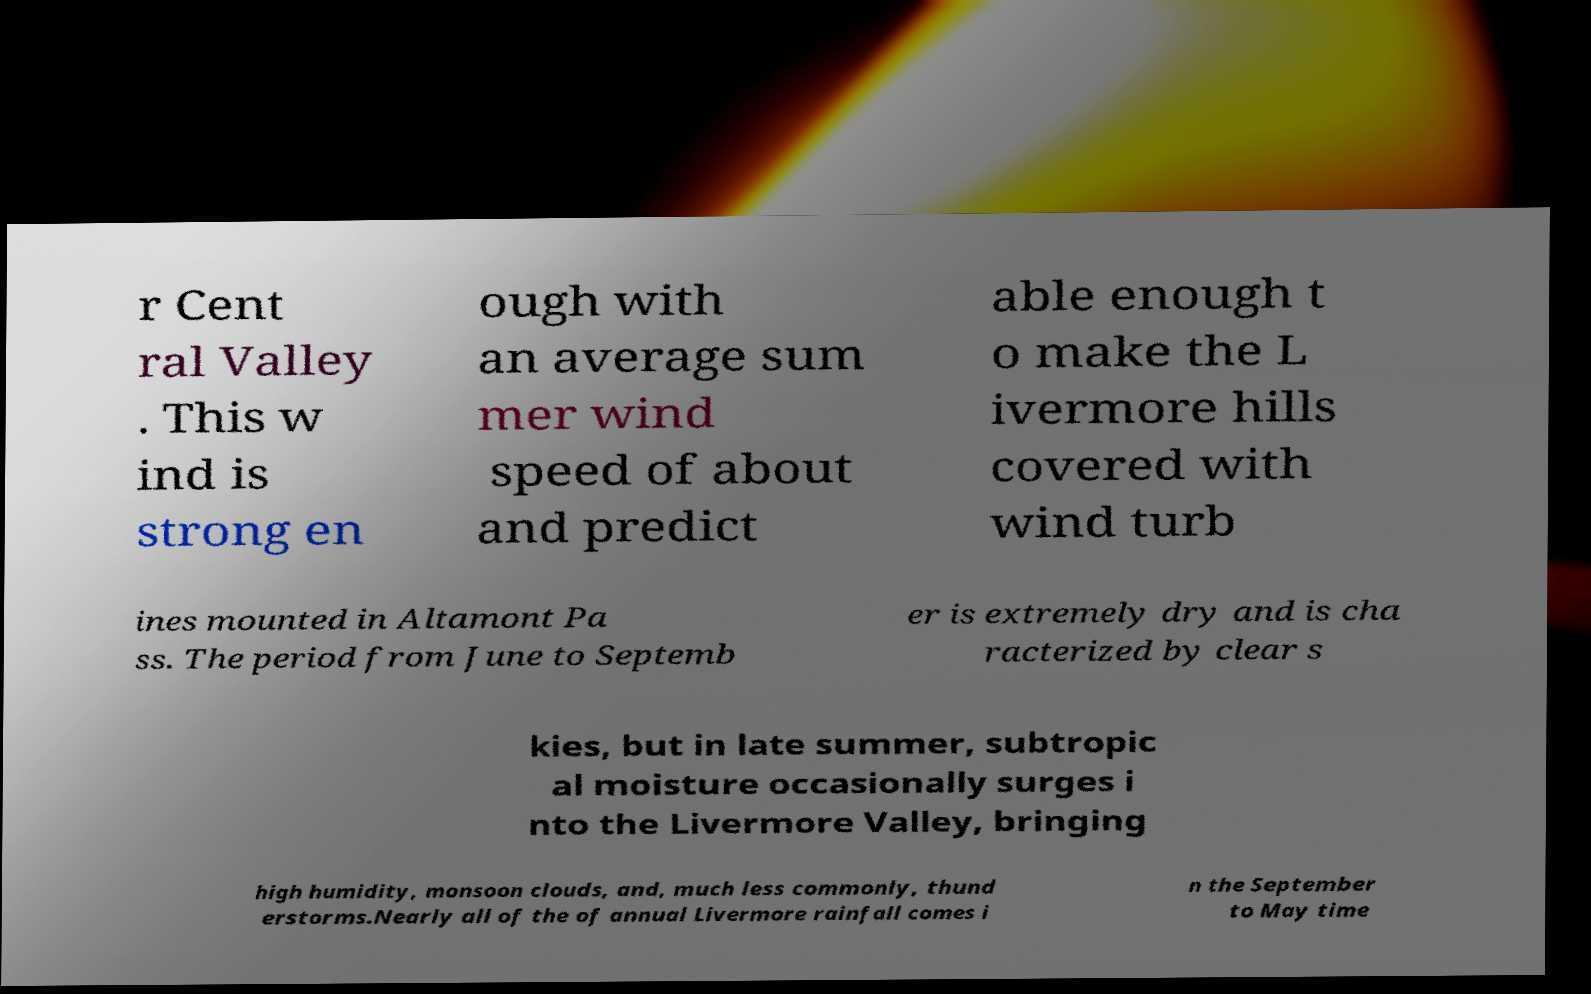Please identify and transcribe the text found in this image. r Cent ral Valley . This w ind is strong en ough with an average sum mer wind speed of about and predict able enough t o make the L ivermore hills covered with wind turb ines mounted in Altamont Pa ss. The period from June to Septemb er is extremely dry and is cha racterized by clear s kies, but in late summer, subtropic al moisture occasionally surges i nto the Livermore Valley, bringing high humidity, monsoon clouds, and, much less commonly, thund erstorms.Nearly all of the of annual Livermore rainfall comes i n the September to May time 